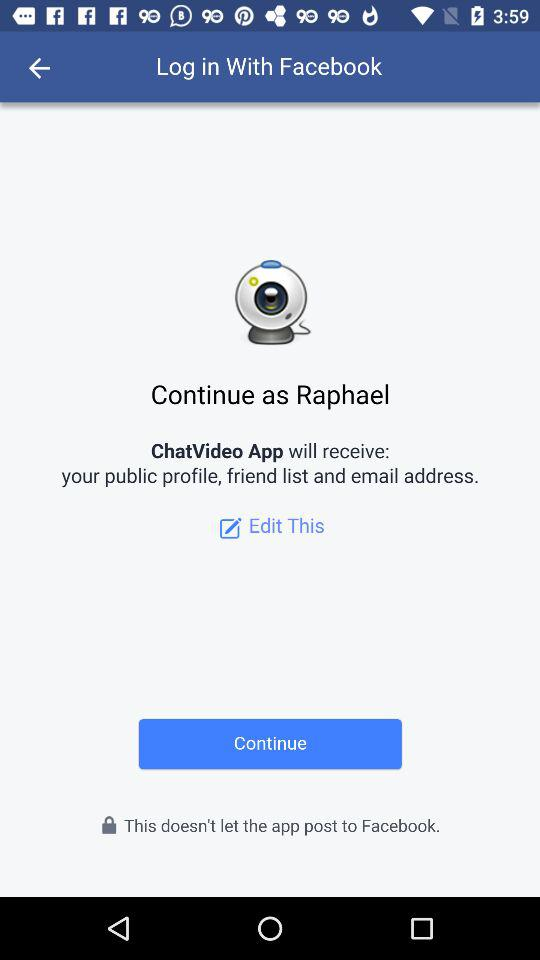Through what application can we log in? You can log in through the "Facebook" application. 